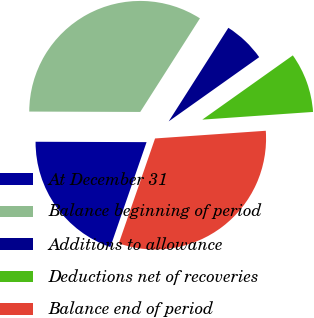Convert chart to OTSL. <chart><loc_0><loc_0><loc_500><loc_500><pie_chart><fcel>At December 31<fcel>Balance beginning of period<fcel>Additions to allowance<fcel>Deductions net of recoveries<fcel>Balance end of period<nl><fcel>19.76%<fcel>33.98%<fcel>6.14%<fcel>8.72%<fcel>31.4%<nl></chart> 